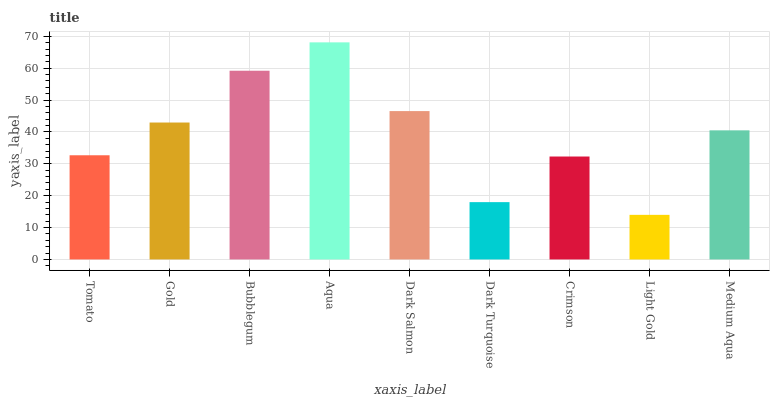Is Light Gold the minimum?
Answer yes or no. Yes. Is Aqua the maximum?
Answer yes or no. Yes. Is Gold the minimum?
Answer yes or no. No. Is Gold the maximum?
Answer yes or no. No. Is Gold greater than Tomato?
Answer yes or no. Yes. Is Tomato less than Gold?
Answer yes or no. Yes. Is Tomato greater than Gold?
Answer yes or no. No. Is Gold less than Tomato?
Answer yes or no. No. Is Medium Aqua the high median?
Answer yes or no. Yes. Is Medium Aqua the low median?
Answer yes or no. Yes. Is Gold the high median?
Answer yes or no. No. Is Tomato the low median?
Answer yes or no. No. 